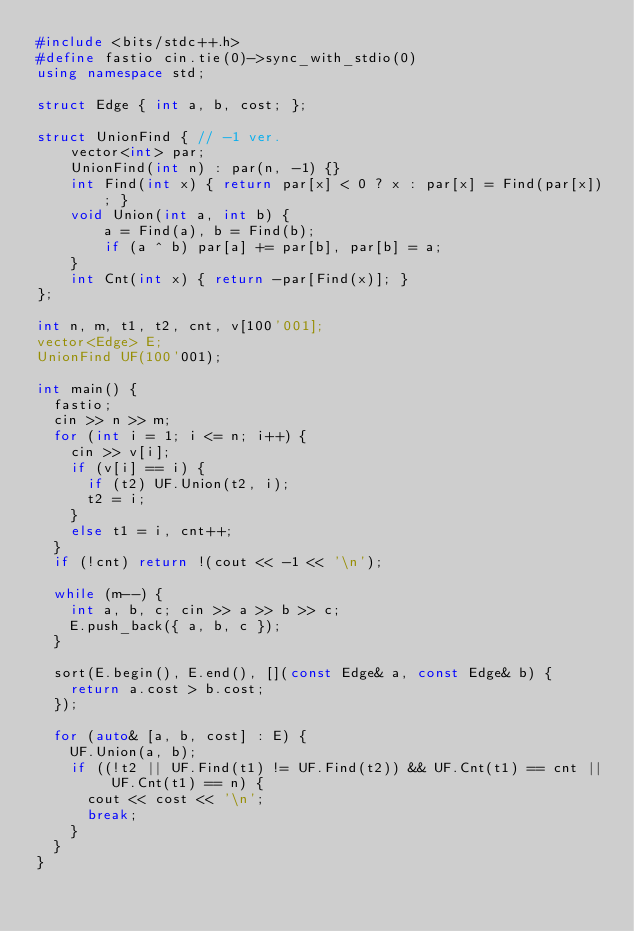Convert code to text. <code><loc_0><loc_0><loc_500><loc_500><_C++_>#include <bits/stdc++.h>
#define fastio cin.tie(0)->sync_with_stdio(0)
using namespace std;

struct Edge { int a, b, cost; };

struct UnionFind { // -1 ver.
    vector<int> par;
    UnionFind(int n) : par(n, -1) {}
    int Find(int x) { return par[x] < 0 ? x : par[x] = Find(par[x]); }
    void Union(int a, int b) {
        a = Find(a), b = Find(b);
        if (a ^ b) par[a] += par[b], par[b] = a;
    }
    int Cnt(int x) { return -par[Find(x)]; }
};

int n, m, t1, t2, cnt, v[100'001];
vector<Edge> E;
UnionFind UF(100'001);

int main() {
	fastio;
	cin >> n >> m;
	for (int i = 1; i <= n; i++) {
		cin >> v[i];
		if (v[i] == i) {
			if (t2) UF.Union(t2, i);
			t2 = i;
		}
		else t1 = i, cnt++;
	}
	if (!cnt) return !(cout << -1 << '\n');

	while (m--) {
		int a, b, c; cin >> a >> b >> c;
		E.push_back({ a, b, c });
	}

	sort(E.begin(), E.end(), [](const Edge& a, const Edge& b) {
		return a.cost > b.cost;
	});

	for (auto& [a, b, cost] : E) {
		UF.Union(a, b);
		if ((!t2 || UF.Find(t1) != UF.Find(t2)) && UF.Cnt(t1) == cnt || UF.Cnt(t1) == n) {
			cout << cost << '\n';
			break;
		}
	}
}</code> 